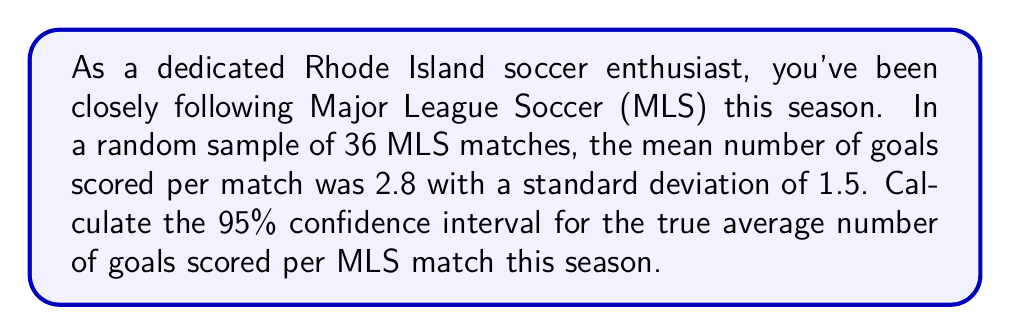Show me your answer to this math problem. Let's calculate the confidence interval step-by-step:

1) We're given:
   - Sample size: $n = 36$
   - Sample mean: $\bar{x} = 2.8$
   - Sample standard deviation: $s = 1.5$
   - Confidence level: 95%

2) For a 95% confidence interval, we use a z-score of 1.96.

3) The formula for the confidence interval is:

   $$\bar{x} \pm z \cdot \frac{s}{\sqrt{n}}$$

4) Let's calculate the standard error:

   $$\frac{s}{\sqrt{n}} = \frac{1.5}{\sqrt{36}} = \frac{1.5}{6} = 0.25$$

5) Now, let's multiply this by our z-score:

   $$1.96 \cdot 0.25 = 0.49$$

6) Finally, we can calculate our confidence interval:

   Lower bound: $2.8 - 0.49 = 2.31$
   Upper bound: $2.8 + 0.49 = 3.29$

Therefore, we are 95% confident that the true average number of goals scored per MLS match this season is between 2.31 and 3.29.
Answer: (2.31, 3.29) 